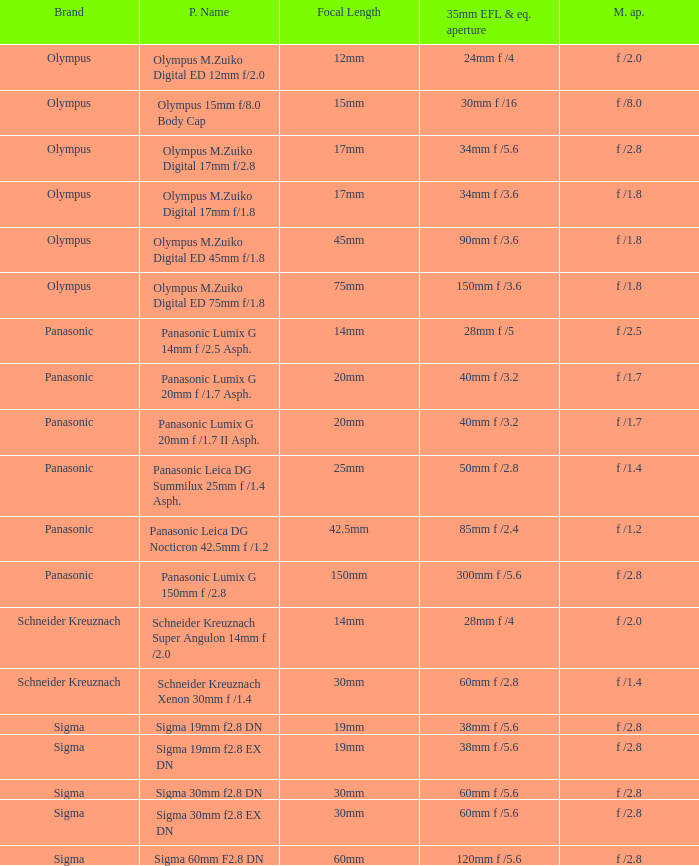What is the maximum aperture of the lens(es) with a focal length of 20mm? F /1.7, f /1.7. 